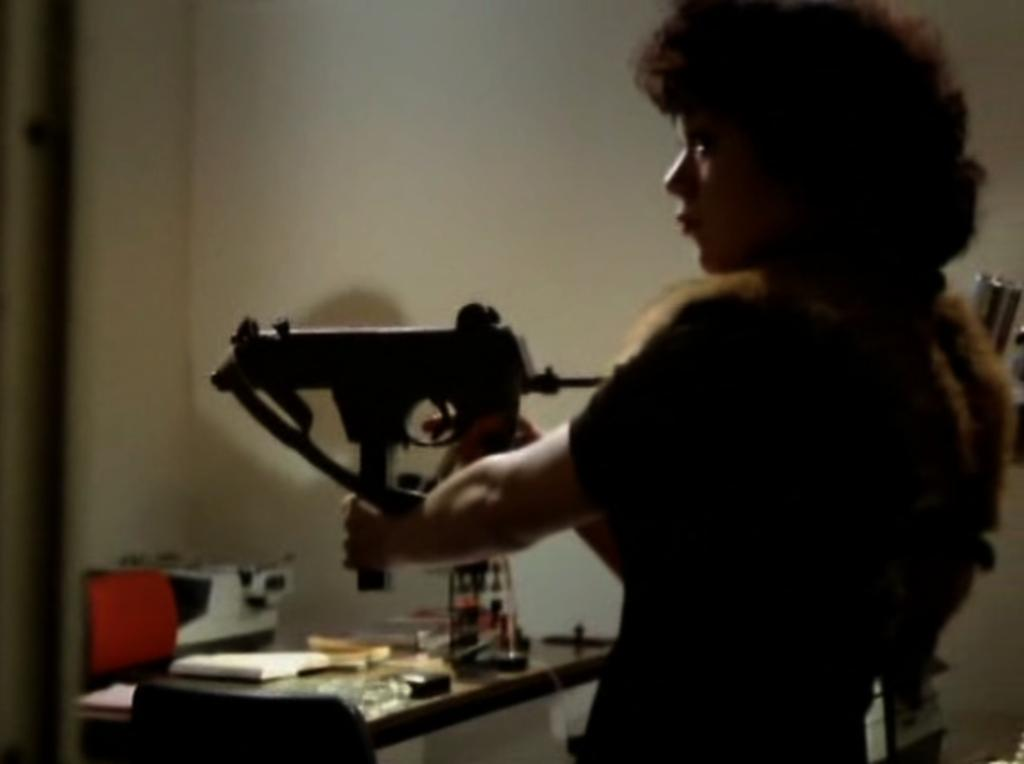What can be seen in the image? There is a person in the image. What is the person holding? The person is holding an object. What else is visible in the image besides the person? There are objects visible behind the person, and there is a table in the image. What is the background of the image? There is a wall at the top of the image. How many frogs are sitting on the plantation in the image? There are no frogs or plantations present in the image. What is the person rubbing on the wall in the image? There is no indication in the image that the person is rubbing anything on the wall. 